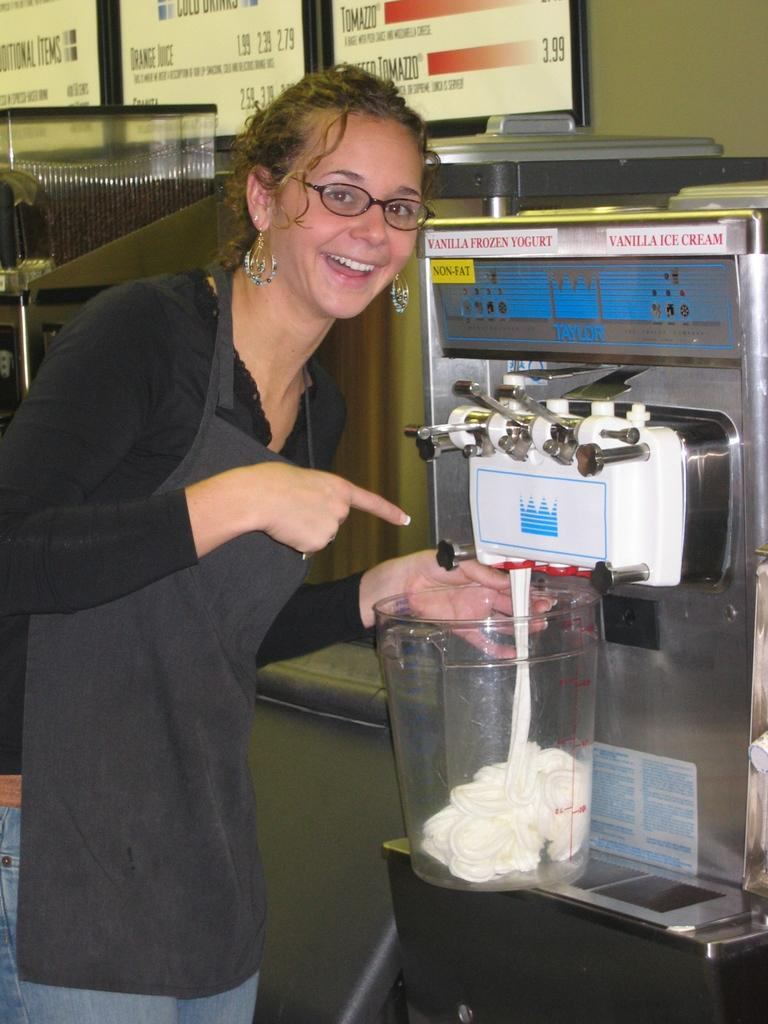<image>
Write a terse but informative summary of the picture. A woman getting ice cream out of a taylor ice cream machine. 